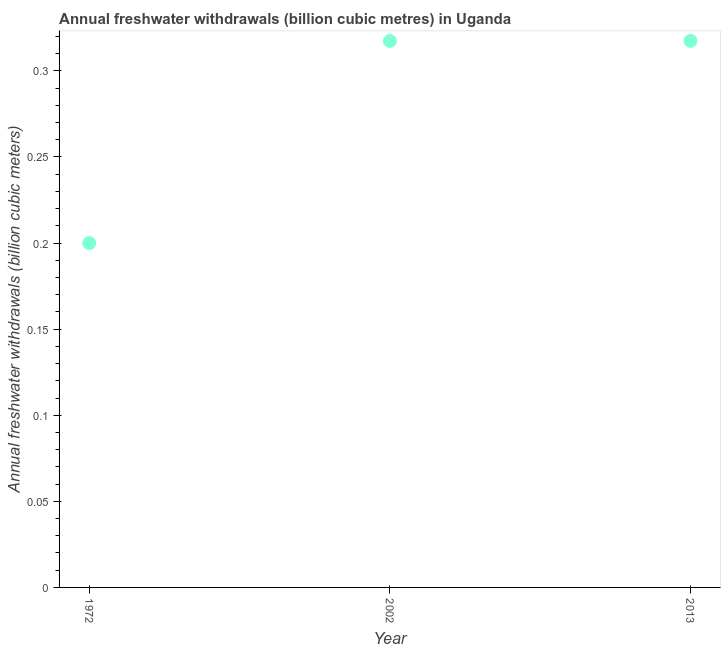What is the annual freshwater withdrawals in 2013?
Your answer should be compact. 0.32. Across all years, what is the maximum annual freshwater withdrawals?
Your answer should be compact. 0.32. Across all years, what is the minimum annual freshwater withdrawals?
Provide a succinct answer. 0.2. In which year was the annual freshwater withdrawals maximum?
Provide a short and direct response. 2002. What is the sum of the annual freshwater withdrawals?
Offer a terse response. 0.83. What is the difference between the annual freshwater withdrawals in 1972 and 2013?
Your answer should be compact. -0.12. What is the average annual freshwater withdrawals per year?
Provide a short and direct response. 0.28. What is the median annual freshwater withdrawals?
Your answer should be very brief. 0.32. What is the ratio of the annual freshwater withdrawals in 1972 to that in 2013?
Ensure brevity in your answer.  0.63. Is the annual freshwater withdrawals in 1972 less than that in 2013?
Provide a short and direct response. Yes. What is the difference between the highest and the second highest annual freshwater withdrawals?
Your response must be concise. 0. What is the difference between the highest and the lowest annual freshwater withdrawals?
Your answer should be compact. 0.12. Are the values on the major ticks of Y-axis written in scientific E-notation?
Your response must be concise. No. Does the graph contain any zero values?
Keep it short and to the point. No. Does the graph contain grids?
Provide a short and direct response. No. What is the title of the graph?
Ensure brevity in your answer.  Annual freshwater withdrawals (billion cubic metres) in Uganda. What is the label or title of the X-axis?
Make the answer very short. Year. What is the label or title of the Y-axis?
Provide a short and direct response. Annual freshwater withdrawals (billion cubic meters). What is the Annual freshwater withdrawals (billion cubic meters) in 2002?
Give a very brief answer. 0.32. What is the Annual freshwater withdrawals (billion cubic meters) in 2013?
Offer a very short reply. 0.32. What is the difference between the Annual freshwater withdrawals (billion cubic meters) in 1972 and 2002?
Your answer should be compact. -0.12. What is the difference between the Annual freshwater withdrawals (billion cubic meters) in 1972 and 2013?
Your response must be concise. -0.12. What is the ratio of the Annual freshwater withdrawals (billion cubic meters) in 1972 to that in 2002?
Keep it short and to the point. 0.63. What is the ratio of the Annual freshwater withdrawals (billion cubic meters) in 1972 to that in 2013?
Make the answer very short. 0.63. 